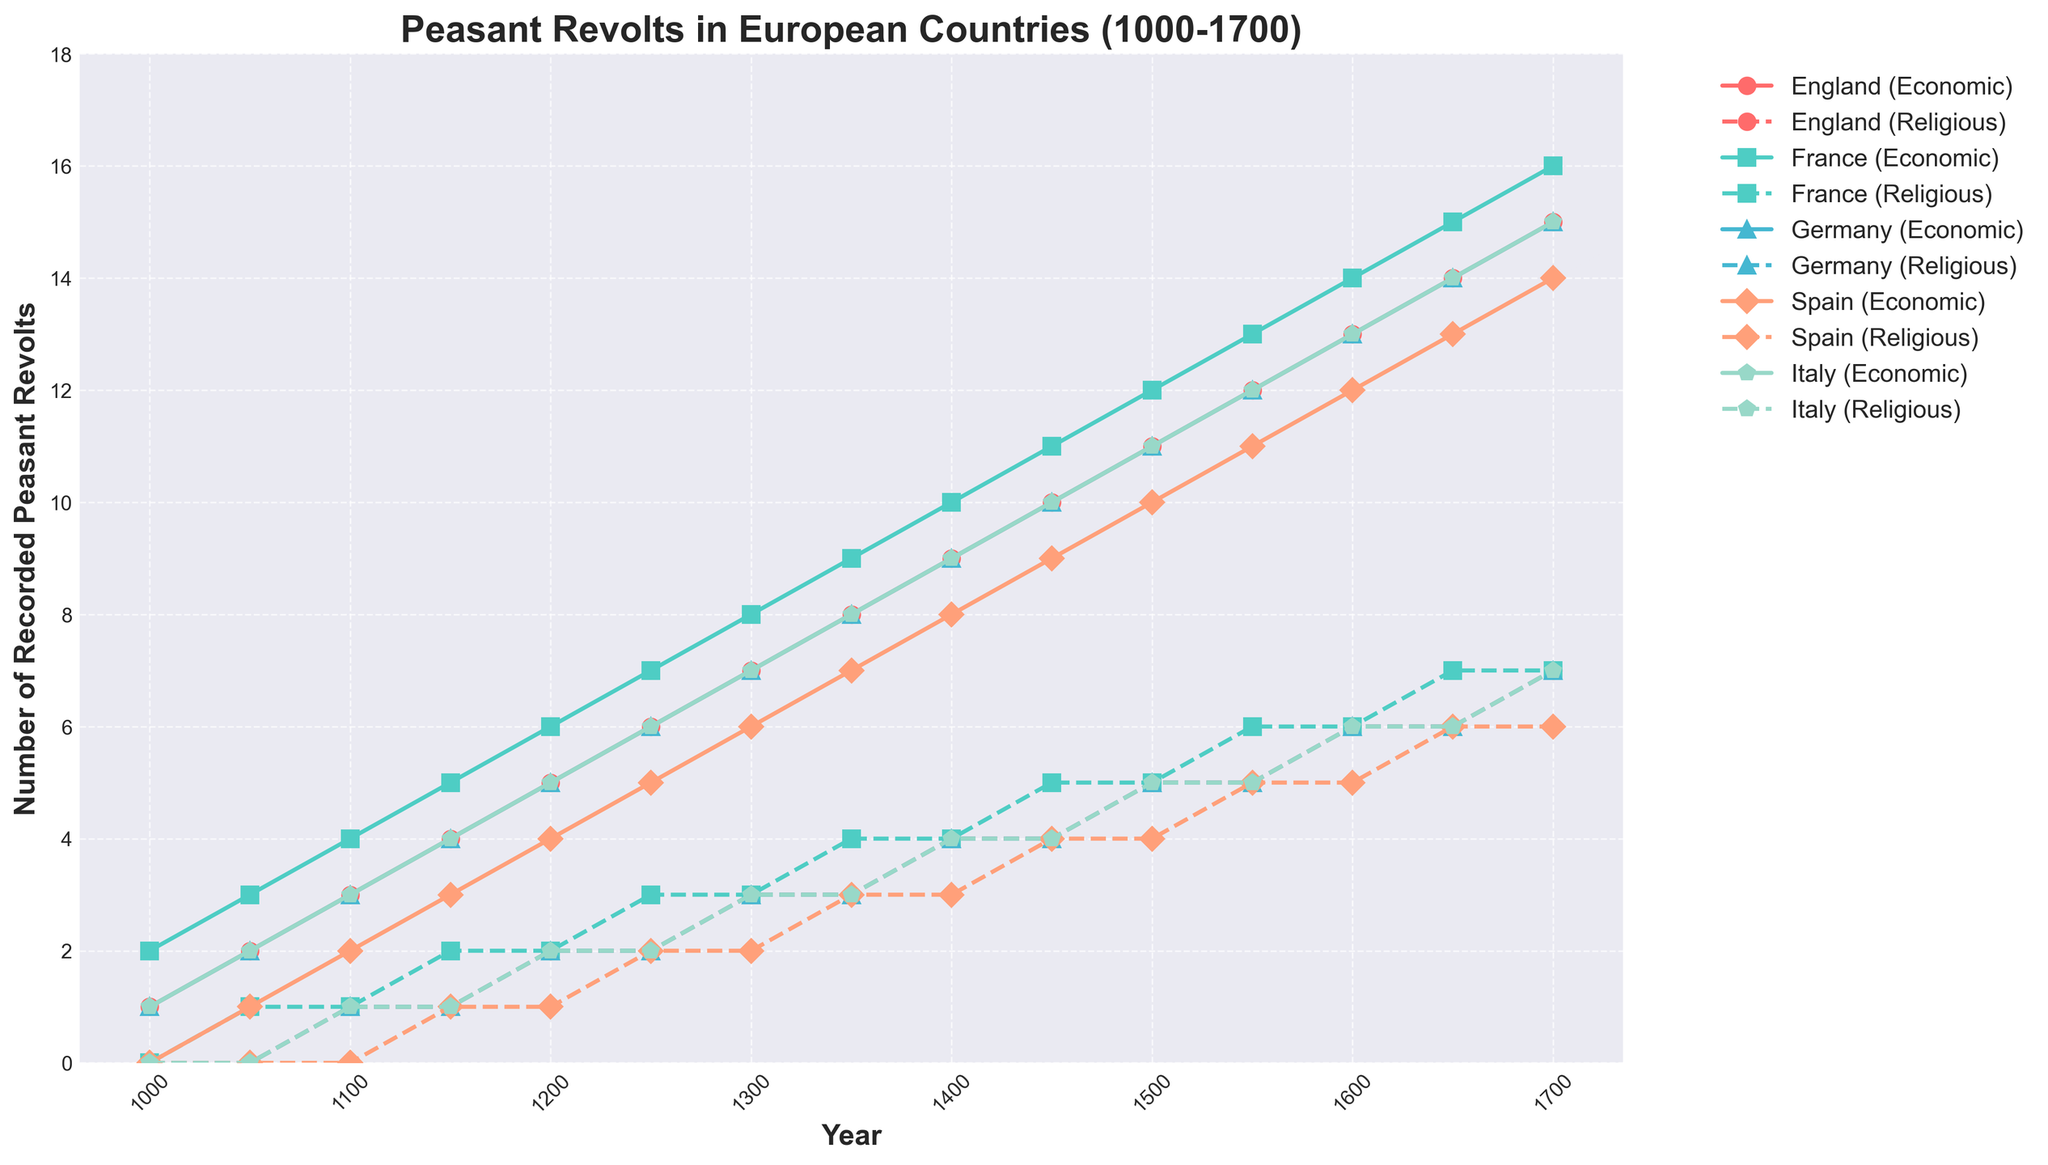What is the total number of recorded peasant revolts in England for the year 1200? To find the total number of recorded peasant revolts in England in 1200, sum the economic and religious causes: 5 (Economic) + 2 (Religious)
Answer: 7 In which country and for which cause did the number of revolts first reach 10? By observing the figure, we see that in 1450, England had 10 economic revolts.
Answer: England, Economic How does the number of recorded religious revolts in Germany in 1400 compare with that in Spain in the same year? In 1400, Germany had 4 religious revolts, whereas Spain had 3 religious revolts. 4 > 3
Answer: Germany had more Which country saw the highest increase in economic revolts from 1250 to 1300? To determine this, calculate the difference in economic revolts for each country between 1250 and 1300: England (7-6=1), France (8-7=1), Germany (7-6=1), Spain (6-5=1), Italy (7-6=1). Each country saw the same increase of 1.
Answer: All countries When did the number of recorded religious revolts in Italy first become equal to that in France? By comparing the data, we find that in 1150, both Italy and France had 1 recorded religious revolt.
Answer: 1150 Which country had the steadiest increase in economic revolts from 1000 to 1700? By closely examining the trends, England's increase in economic revolts is steady as it increments by 1 per 50 years continuously.
Answer: England What was the total number of revolts (both economic and religious) in Spain from 1000 to 1700? Sum the economic and religious revolts for Spain over all the years: 0+0+1+0+2+0+3+1+4+1+5+2+6+2+7+3+8+3+9+4+10+4+11+5+12+5+13+6+14+6 = 94.
Answer: 94 In which year did France see an equal number of economic and religious revolts for the first time? France had equal numbers of economic and religious revolts (1 each) in the year 1100. This is the first occurrence.
Answer: 1100 Compare the total number of recorded peasant revolts in Italy and Spain for the year 1650. Which country had more revolts? For Italy, the total number in 1650 is 14 (economic) + 6 (religious) = 20. For Spain, it is 13 (economic) + 6 (religious) = 19. Italy had more revolts.
Answer: Italy Did any country experience a decrease in the number of recorded revolts between any two periods listed? Observing the data across all periods for each country, none of the countries experienced a decrease in recorded revolts. Every country shows either a steady increase or constant value between periods.
Answer: No 